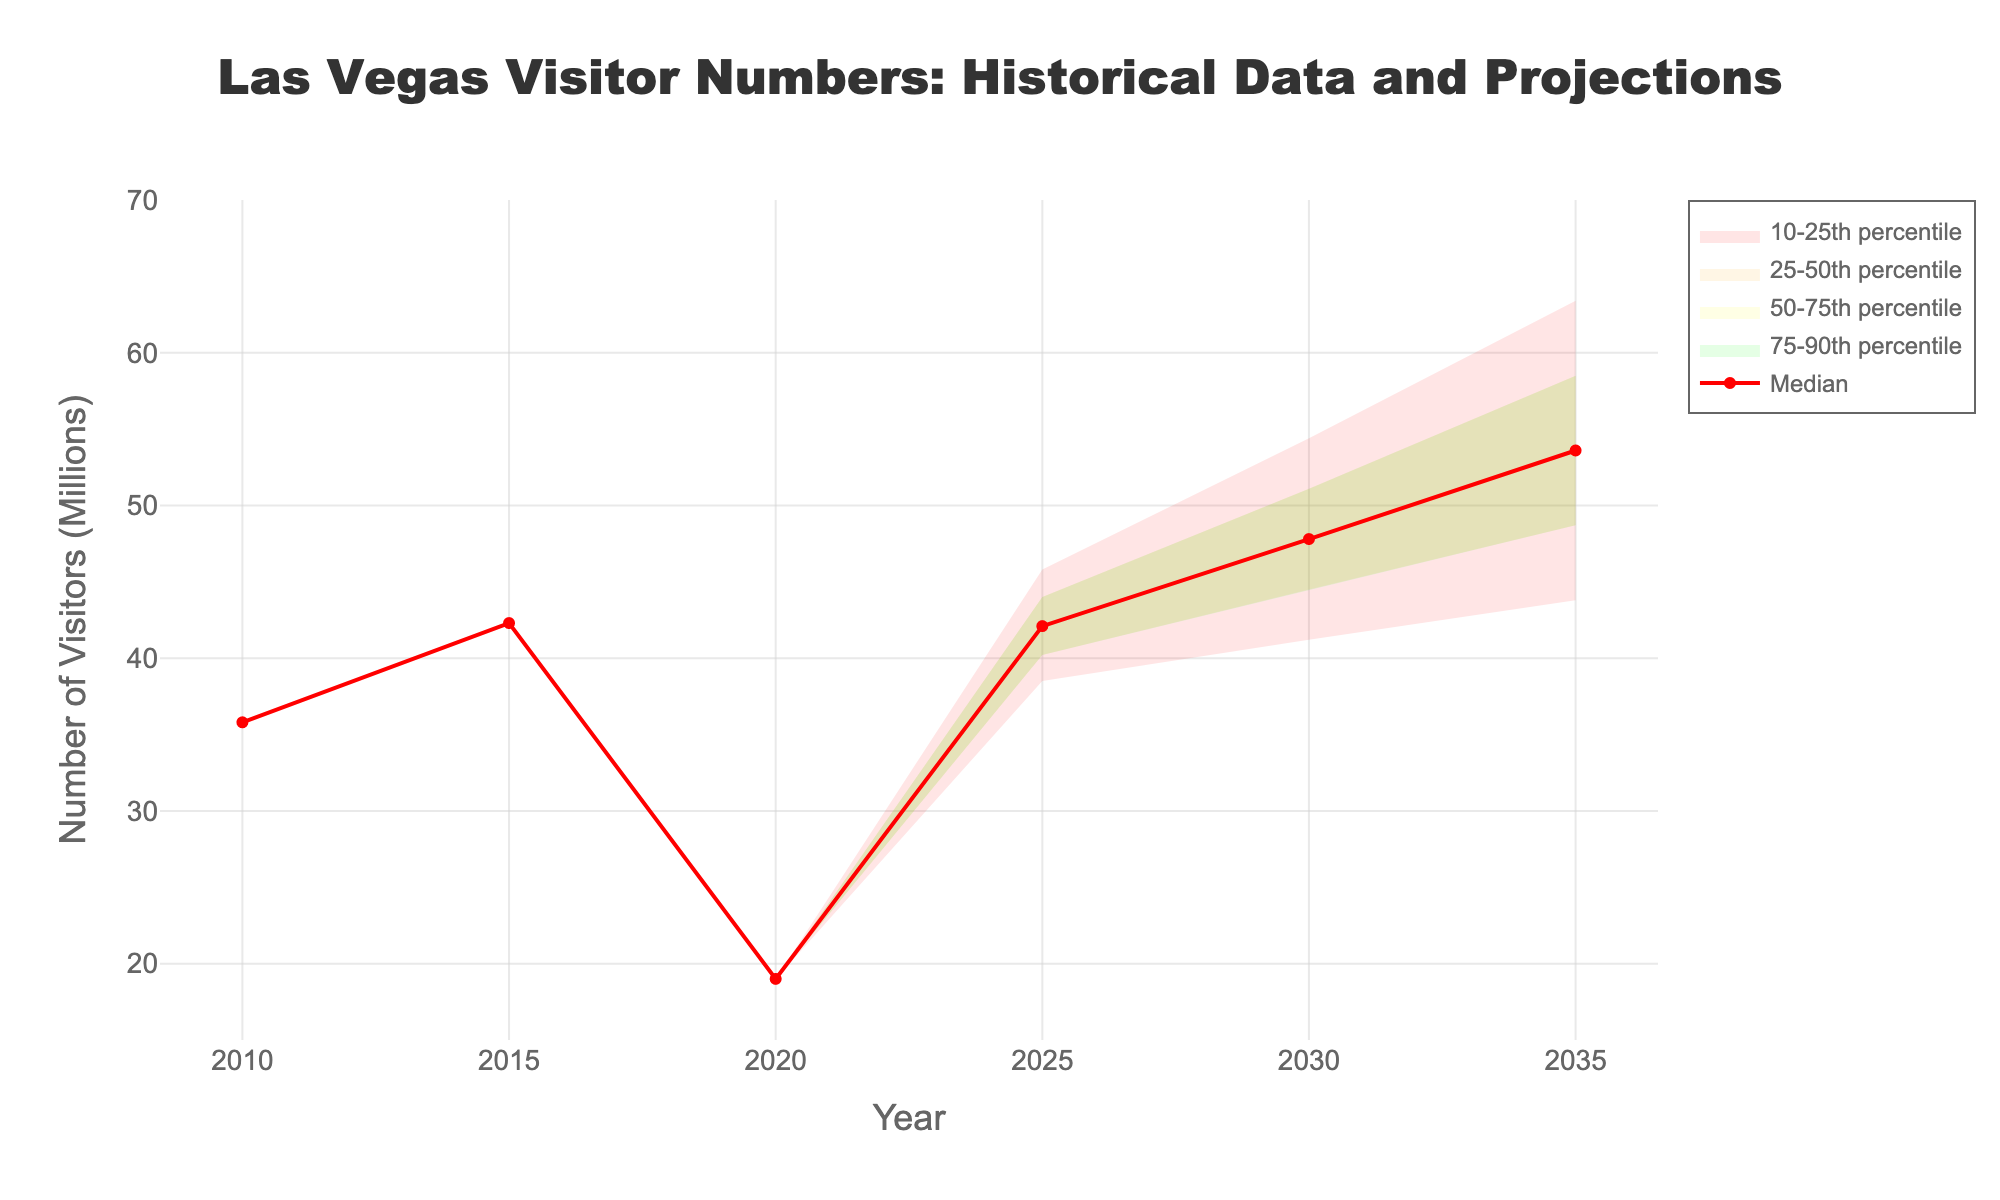What is the title of the chart? The title is located at the top center of the chart and it reads 'Las Vegas Visitor Numbers: Historical Data and Projections'. Relate the title content with the data shown in the figure.
Answer: Las Vegas Visitor Numbers: Historical Data and Projections What is the y-axis representing? The y-axis title states 'Number of Visitors (Millions)', indicating it represents the number of visitors to Las Vegas in millions.
Answer: Number of Visitors (Millions) How many data points are there for each percentile range? There are 6 vertical data points for each percentile range corresponding to the years 2010, 2015, 2020, 2025, 2030, and 2035.
Answer: 6 What is the median projected number of visitors for the year 2035? The median (red line) projected number of visitors for 2035 is positioned on the y-axis at 53.6 million.
Answer: 53.6 million Between which years did the median number of visitors experience the greatest projected increase? Compare the median values for each year and find the largest difference. For instance, the difference between 2030 and 2035 is the largest (53.6 - 47.8 = 5.8 million).
Answer: From 2030 to 2035 What was the significant drop in visitor numbers in historical data and which period did it occur? Identify the sharp decline by looking at the historical data before the projection starts. The drop from 42.3 million in 2015 to 19.0 million in 2020 is significant.
Answer: Between 2015 and 2020 How do the projections for 2025 compare to historical visitor numbers in 2015? The median visitor number projection for 2025 is 42.1 million, which is very close to the 42.3 million visitors in 2015. This involves comparing median values between both years.
Answer: Very similar What is the highest possible number of visitors projected in 2035 according to the chart? The highest possible number is indicated by the uppermost boundary of the fan for 2035. It is at 63.4 million visitors.
Answer: 63.4 million How does the range of projections change from 2025 to 2035? Compare the range (difference between the highest and lowest projections) for 2025 and 2035. 2025 ranges from 38.5 to 45.8 million (a span of 7.3 million), while 2035 ranges from 43.8 to 63.4 million (a span of 19.6 million).
Answer: Range increases Can you summarize the overall trend from 2010 to 2035? The median visitor number rises from 35.8 in 2010, peaks in 2015, drops sharply in 2020, and then steadily increases in projections up to 2035. This showcases an initial rise, a significant drop, and a steady increase.
Answer: Initial rise, sharp drop, steady increase 